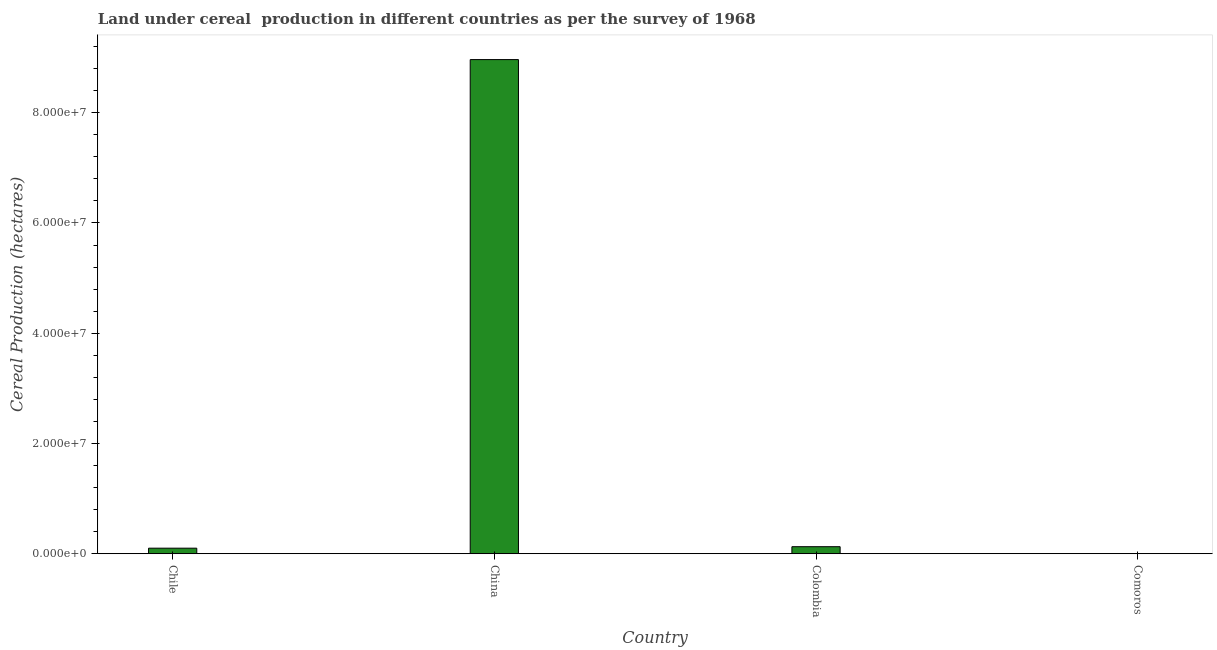Does the graph contain grids?
Offer a very short reply. No. What is the title of the graph?
Provide a short and direct response. Land under cereal  production in different countries as per the survey of 1968. What is the label or title of the X-axis?
Keep it short and to the point. Country. What is the label or title of the Y-axis?
Give a very brief answer. Cereal Production (hectares). What is the land under cereal production in Comoros?
Keep it short and to the point. 1.22e+04. Across all countries, what is the maximum land under cereal production?
Offer a terse response. 8.96e+07. Across all countries, what is the minimum land under cereal production?
Offer a terse response. 1.22e+04. In which country was the land under cereal production maximum?
Your response must be concise. China. In which country was the land under cereal production minimum?
Provide a succinct answer. Comoros. What is the sum of the land under cereal production?
Provide a short and direct response. 9.19e+07. What is the difference between the land under cereal production in Chile and Colombia?
Ensure brevity in your answer.  -2.69e+05. What is the average land under cereal production per country?
Your response must be concise. 2.30e+07. What is the median land under cereal production?
Provide a succinct answer. 1.14e+06. What is the ratio of the land under cereal production in Colombia to that in Comoros?
Ensure brevity in your answer.  104.66. Is the land under cereal production in China less than that in Comoros?
Provide a short and direct response. No. What is the difference between the highest and the second highest land under cereal production?
Provide a short and direct response. 8.84e+07. What is the difference between the highest and the lowest land under cereal production?
Offer a terse response. 8.96e+07. In how many countries, is the land under cereal production greater than the average land under cereal production taken over all countries?
Make the answer very short. 1. How many bars are there?
Make the answer very short. 4. What is the difference between two consecutive major ticks on the Y-axis?
Give a very brief answer. 2.00e+07. Are the values on the major ticks of Y-axis written in scientific E-notation?
Your answer should be compact. Yes. What is the Cereal Production (hectares) of Chile?
Your answer should be compact. 1.01e+06. What is the Cereal Production (hectares) in China?
Your answer should be compact. 8.96e+07. What is the Cereal Production (hectares) in Colombia?
Your answer should be compact. 1.28e+06. What is the Cereal Production (hectares) of Comoros?
Provide a short and direct response. 1.22e+04. What is the difference between the Cereal Production (hectares) in Chile and China?
Make the answer very short. -8.86e+07. What is the difference between the Cereal Production (hectares) in Chile and Colombia?
Offer a terse response. -2.69e+05. What is the difference between the Cereal Production (hectares) in Chile and Comoros?
Ensure brevity in your answer.  9.96e+05. What is the difference between the Cereal Production (hectares) in China and Colombia?
Make the answer very short. 8.84e+07. What is the difference between the Cereal Production (hectares) in China and Comoros?
Offer a very short reply. 8.96e+07. What is the difference between the Cereal Production (hectares) in Colombia and Comoros?
Keep it short and to the point. 1.26e+06. What is the ratio of the Cereal Production (hectares) in Chile to that in China?
Your response must be concise. 0.01. What is the ratio of the Cereal Production (hectares) in Chile to that in Colombia?
Ensure brevity in your answer.  0.79. What is the ratio of the Cereal Production (hectares) in Chile to that in Comoros?
Your answer should be compact. 82.65. What is the ratio of the Cereal Production (hectares) in China to that in Colombia?
Make the answer very short. 70.2. What is the ratio of the Cereal Production (hectares) in China to that in Comoros?
Make the answer very short. 7347.79. What is the ratio of the Cereal Production (hectares) in Colombia to that in Comoros?
Your answer should be compact. 104.66. 